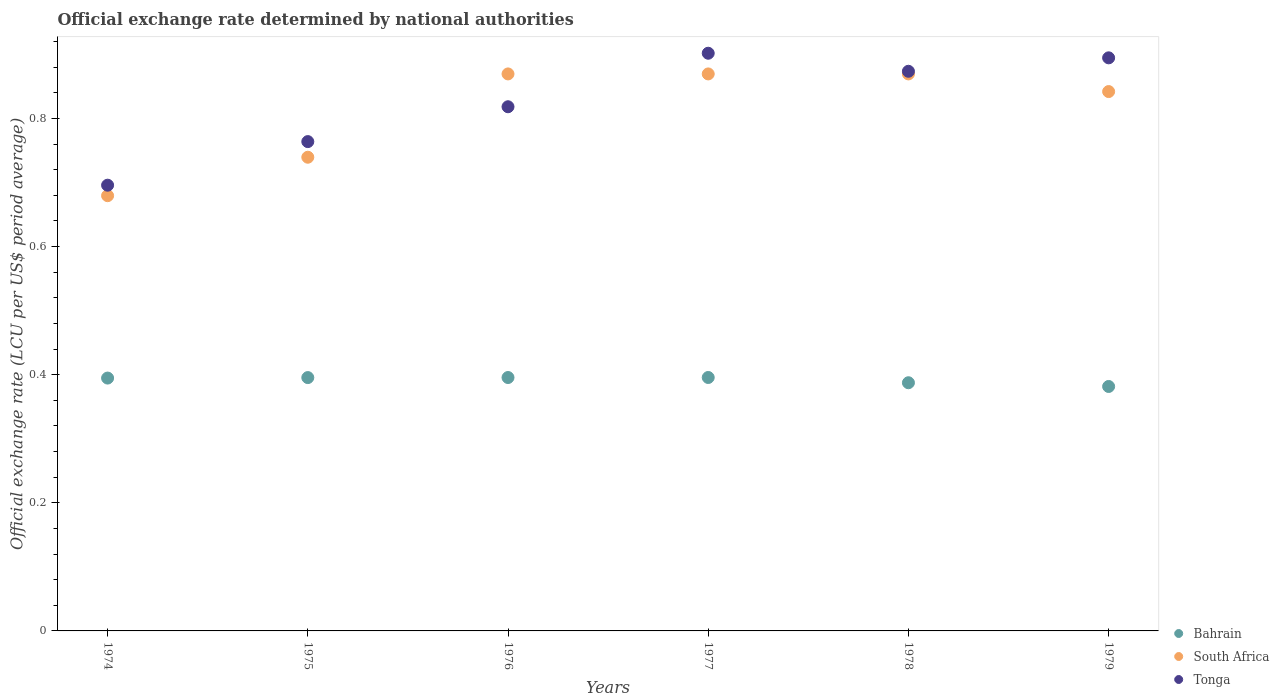What is the official exchange rate in South Africa in 1977?
Provide a succinct answer. 0.87. Across all years, what is the maximum official exchange rate in Bahrain?
Provide a succinct answer. 0.4. Across all years, what is the minimum official exchange rate in Bahrain?
Give a very brief answer. 0.38. In which year was the official exchange rate in South Africa maximum?
Your answer should be compact. 1976. In which year was the official exchange rate in South Africa minimum?
Provide a succinct answer. 1974. What is the total official exchange rate in Bahrain in the graph?
Your answer should be compact. 2.35. What is the difference between the official exchange rate in South Africa in 1975 and that in 1979?
Your response must be concise. -0.1. What is the difference between the official exchange rate in Bahrain in 1976 and the official exchange rate in South Africa in 1977?
Your answer should be very brief. -0.47. What is the average official exchange rate in South Africa per year?
Keep it short and to the point. 0.81. In the year 1977, what is the difference between the official exchange rate in Tonga and official exchange rate in Bahrain?
Offer a very short reply. 0.51. In how many years, is the official exchange rate in Tonga greater than 0.04 LCU?
Offer a terse response. 6. What is the ratio of the official exchange rate in Tonga in 1974 to that in 1978?
Keep it short and to the point. 0.8. Is the difference between the official exchange rate in Tonga in 1976 and 1979 greater than the difference between the official exchange rate in Bahrain in 1976 and 1979?
Make the answer very short. No. What is the difference between the highest and the second highest official exchange rate in South Africa?
Offer a very short reply. 0. What is the difference between the highest and the lowest official exchange rate in Bahrain?
Give a very brief answer. 0.01. Is it the case that in every year, the sum of the official exchange rate in Tonga and official exchange rate in Bahrain  is greater than the official exchange rate in South Africa?
Offer a very short reply. Yes. Does the official exchange rate in Tonga monotonically increase over the years?
Your answer should be compact. No. Is the official exchange rate in South Africa strictly less than the official exchange rate in Bahrain over the years?
Your response must be concise. No. How many dotlines are there?
Your answer should be compact. 3. How many years are there in the graph?
Provide a short and direct response. 6. Does the graph contain any zero values?
Provide a short and direct response. No. Does the graph contain grids?
Your answer should be compact. No. How are the legend labels stacked?
Provide a short and direct response. Vertical. What is the title of the graph?
Provide a succinct answer. Official exchange rate determined by national authorities. Does "Bosnia and Herzegovina" appear as one of the legend labels in the graph?
Ensure brevity in your answer.  No. What is the label or title of the X-axis?
Offer a terse response. Years. What is the label or title of the Y-axis?
Give a very brief answer. Official exchange rate (LCU per US$ period average). What is the Official exchange rate (LCU per US$ period average) of Bahrain in 1974?
Keep it short and to the point. 0.39. What is the Official exchange rate (LCU per US$ period average) in South Africa in 1974?
Your response must be concise. 0.68. What is the Official exchange rate (LCU per US$ period average) of Tonga in 1974?
Provide a succinct answer. 0.7. What is the Official exchange rate (LCU per US$ period average) of Bahrain in 1975?
Give a very brief answer. 0.4. What is the Official exchange rate (LCU per US$ period average) in South Africa in 1975?
Your answer should be compact. 0.74. What is the Official exchange rate (LCU per US$ period average) of Tonga in 1975?
Give a very brief answer. 0.76. What is the Official exchange rate (LCU per US$ period average) of Bahrain in 1976?
Your answer should be very brief. 0.4. What is the Official exchange rate (LCU per US$ period average) in South Africa in 1976?
Offer a terse response. 0.87. What is the Official exchange rate (LCU per US$ period average) in Tonga in 1976?
Ensure brevity in your answer.  0.82. What is the Official exchange rate (LCU per US$ period average) in Bahrain in 1977?
Keep it short and to the point. 0.4. What is the Official exchange rate (LCU per US$ period average) in South Africa in 1977?
Keep it short and to the point. 0.87. What is the Official exchange rate (LCU per US$ period average) of Tonga in 1977?
Ensure brevity in your answer.  0.9. What is the Official exchange rate (LCU per US$ period average) in Bahrain in 1978?
Give a very brief answer. 0.39. What is the Official exchange rate (LCU per US$ period average) in South Africa in 1978?
Provide a short and direct response. 0.87. What is the Official exchange rate (LCU per US$ period average) in Tonga in 1978?
Offer a terse response. 0.87. What is the Official exchange rate (LCU per US$ period average) of Bahrain in 1979?
Offer a very short reply. 0.38. What is the Official exchange rate (LCU per US$ period average) of South Africa in 1979?
Make the answer very short. 0.84. What is the Official exchange rate (LCU per US$ period average) of Tonga in 1979?
Offer a very short reply. 0.89. Across all years, what is the maximum Official exchange rate (LCU per US$ period average) in Bahrain?
Make the answer very short. 0.4. Across all years, what is the maximum Official exchange rate (LCU per US$ period average) in South Africa?
Keep it short and to the point. 0.87. Across all years, what is the maximum Official exchange rate (LCU per US$ period average) of Tonga?
Ensure brevity in your answer.  0.9. Across all years, what is the minimum Official exchange rate (LCU per US$ period average) in Bahrain?
Keep it short and to the point. 0.38. Across all years, what is the minimum Official exchange rate (LCU per US$ period average) in South Africa?
Your response must be concise. 0.68. Across all years, what is the minimum Official exchange rate (LCU per US$ period average) in Tonga?
Offer a terse response. 0.7. What is the total Official exchange rate (LCU per US$ period average) of Bahrain in the graph?
Make the answer very short. 2.35. What is the total Official exchange rate (LCU per US$ period average) of South Africa in the graph?
Offer a terse response. 4.87. What is the total Official exchange rate (LCU per US$ period average) of Tonga in the graph?
Give a very brief answer. 4.95. What is the difference between the Official exchange rate (LCU per US$ period average) of Bahrain in 1974 and that in 1975?
Offer a terse response. -0. What is the difference between the Official exchange rate (LCU per US$ period average) of South Africa in 1974 and that in 1975?
Offer a very short reply. -0.06. What is the difference between the Official exchange rate (LCU per US$ period average) of Tonga in 1974 and that in 1975?
Provide a succinct answer. -0.07. What is the difference between the Official exchange rate (LCU per US$ period average) of Bahrain in 1974 and that in 1976?
Provide a succinct answer. -0. What is the difference between the Official exchange rate (LCU per US$ period average) in South Africa in 1974 and that in 1976?
Keep it short and to the point. -0.19. What is the difference between the Official exchange rate (LCU per US$ period average) of Tonga in 1974 and that in 1976?
Offer a very short reply. -0.12. What is the difference between the Official exchange rate (LCU per US$ period average) of Bahrain in 1974 and that in 1977?
Ensure brevity in your answer.  -0. What is the difference between the Official exchange rate (LCU per US$ period average) in South Africa in 1974 and that in 1977?
Your answer should be very brief. -0.19. What is the difference between the Official exchange rate (LCU per US$ period average) of Tonga in 1974 and that in 1977?
Your response must be concise. -0.21. What is the difference between the Official exchange rate (LCU per US$ period average) in Bahrain in 1974 and that in 1978?
Your response must be concise. 0.01. What is the difference between the Official exchange rate (LCU per US$ period average) in South Africa in 1974 and that in 1978?
Offer a terse response. -0.19. What is the difference between the Official exchange rate (LCU per US$ period average) of Tonga in 1974 and that in 1978?
Offer a very short reply. -0.18. What is the difference between the Official exchange rate (LCU per US$ period average) of Bahrain in 1974 and that in 1979?
Keep it short and to the point. 0.01. What is the difference between the Official exchange rate (LCU per US$ period average) of South Africa in 1974 and that in 1979?
Your answer should be very brief. -0.16. What is the difference between the Official exchange rate (LCU per US$ period average) in Tonga in 1974 and that in 1979?
Provide a short and direct response. -0.2. What is the difference between the Official exchange rate (LCU per US$ period average) of Bahrain in 1975 and that in 1976?
Your response must be concise. -0. What is the difference between the Official exchange rate (LCU per US$ period average) of South Africa in 1975 and that in 1976?
Offer a very short reply. -0.13. What is the difference between the Official exchange rate (LCU per US$ period average) in Tonga in 1975 and that in 1976?
Keep it short and to the point. -0.05. What is the difference between the Official exchange rate (LCU per US$ period average) in Bahrain in 1975 and that in 1977?
Give a very brief answer. -0. What is the difference between the Official exchange rate (LCU per US$ period average) in South Africa in 1975 and that in 1977?
Offer a terse response. -0.13. What is the difference between the Official exchange rate (LCU per US$ period average) in Tonga in 1975 and that in 1977?
Give a very brief answer. -0.14. What is the difference between the Official exchange rate (LCU per US$ period average) of Bahrain in 1975 and that in 1978?
Provide a short and direct response. 0.01. What is the difference between the Official exchange rate (LCU per US$ period average) in South Africa in 1975 and that in 1978?
Give a very brief answer. -0.13. What is the difference between the Official exchange rate (LCU per US$ period average) of Tonga in 1975 and that in 1978?
Your answer should be compact. -0.11. What is the difference between the Official exchange rate (LCU per US$ period average) in Bahrain in 1975 and that in 1979?
Provide a short and direct response. 0.01. What is the difference between the Official exchange rate (LCU per US$ period average) in South Africa in 1975 and that in 1979?
Keep it short and to the point. -0.1. What is the difference between the Official exchange rate (LCU per US$ period average) of Tonga in 1975 and that in 1979?
Your answer should be compact. -0.13. What is the difference between the Official exchange rate (LCU per US$ period average) of Bahrain in 1976 and that in 1977?
Provide a succinct answer. -0. What is the difference between the Official exchange rate (LCU per US$ period average) of South Africa in 1976 and that in 1977?
Offer a very short reply. 0. What is the difference between the Official exchange rate (LCU per US$ period average) of Tonga in 1976 and that in 1977?
Provide a succinct answer. -0.08. What is the difference between the Official exchange rate (LCU per US$ period average) of Bahrain in 1976 and that in 1978?
Offer a terse response. 0.01. What is the difference between the Official exchange rate (LCU per US$ period average) in South Africa in 1976 and that in 1978?
Your answer should be very brief. 0. What is the difference between the Official exchange rate (LCU per US$ period average) in Tonga in 1976 and that in 1978?
Your answer should be compact. -0.06. What is the difference between the Official exchange rate (LCU per US$ period average) in Bahrain in 1976 and that in 1979?
Provide a succinct answer. 0.01. What is the difference between the Official exchange rate (LCU per US$ period average) of South Africa in 1976 and that in 1979?
Provide a short and direct response. 0.03. What is the difference between the Official exchange rate (LCU per US$ period average) of Tonga in 1976 and that in 1979?
Offer a terse response. -0.08. What is the difference between the Official exchange rate (LCU per US$ period average) of Bahrain in 1977 and that in 1978?
Your response must be concise. 0.01. What is the difference between the Official exchange rate (LCU per US$ period average) of South Africa in 1977 and that in 1978?
Provide a short and direct response. 0. What is the difference between the Official exchange rate (LCU per US$ period average) in Tonga in 1977 and that in 1978?
Your response must be concise. 0.03. What is the difference between the Official exchange rate (LCU per US$ period average) in Bahrain in 1977 and that in 1979?
Offer a very short reply. 0.01. What is the difference between the Official exchange rate (LCU per US$ period average) in South Africa in 1977 and that in 1979?
Offer a very short reply. 0.03. What is the difference between the Official exchange rate (LCU per US$ period average) of Tonga in 1977 and that in 1979?
Ensure brevity in your answer.  0.01. What is the difference between the Official exchange rate (LCU per US$ period average) of Bahrain in 1978 and that in 1979?
Your answer should be compact. 0.01. What is the difference between the Official exchange rate (LCU per US$ period average) of South Africa in 1978 and that in 1979?
Ensure brevity in your answer.  0.03. What is the difference between the Official exchange rate (LCU per US$ period average) in Tonga in 1978 and that in 1979?
Give a very brief answer. -0.02. What is the difference between the Official exchange rate (LCU per US$ period average) in Bahrain in 1974 and the Official exchange rate (LCU per US$ period average) in South Africa in 1975?
Your answer should be very brief. -0.34. What is the difference between the Official exchange rate (LCU per US$ period average) in Bahrain in 1974 and the Official exchange rate (LCU per US$ period average) in Tonga in 1975?
Offer a very short reply. -0.37. What is the difference between the Official exchange rate (LCU per US$ period average) of South Africa in 1974 and the Official exchange rate (LCU per US$ period average) of Tonga in 1975?
Provide a succinct answer. -0.08. What is the difference between the Official exchange rate (LCU per US$ period average) of Bahrain in 1974 and the Official exchange rate (LCU per US$ period average) of South Africa in 1976?
Keep it short and to the point. -0.47. What is the difference between the Official exchange rate (LCU per US$ period average) in Bahrain in 1974 and the Official exchange rate (LCU per US$ period average) in Tonga in 1976?
Keep it short and to the point. -0.42. What is the difference between the Official exchange rate (LCU per US$ period average) of South Africa in 1974 and the Official exchange rate (LCU per US$ period average) of Tonga in 1976?
Ensure brevity in your answer.  -0.14. What is the difference between the Official exchange rate (LCU per US$ period average) in Bahrain in 1974 and the Official exchange rate (LCU per US$ period average) in South Africa in 1977?
Give a very brief answer. -0.47. What is the difference between the Official exchange rate (LCU per US$ period average) in Bahrain in 1974 and the Official exchange rate (LCU per US$ period average) in Tonga in 1977?
Offer a very short reply. -0.51. What is the difference between the Official exchange rate (LCU per US$ period average) in South Africa in 1974 and the Official exchange rate (LCU per US$ period average) in Tonga in 1977?
Offer a terse response. -0.22. What is the difference between the Official exchange rate (LCU per US$ period average) in Bahrain in 1974 and the Official exchange rate (LCU per US$ period average) in South Africa in 1978?
Ensure brevity in your answer.  -0.47. What is the difference between the Official exchange rate (LCU per US$ period average) of Bahrain in 1974 and the Official exchange rate (LCU per US$ period average) of Tonga in 1978?
Provide a succinct answer. -0.48. What is the difference between the Official exchange rate (LCU per US$ period average) of South Africa in 1974 and the Official exchange rate (LCU per US$ period average) of Tonga in 1978?
Your response must be concise. -0.19. What is the difference between the Official exchange rate (LCU per US$ period average) of Bahrain in 1974 and the Official exchange rate (LCU per US$ period average) of South Africa in 1979?
Keep it short and to the point. -0.45. What is the difference between the Official exchange rate (LCU per US$ period average) of Bahrain in 1974 and the Official exchange rate (LCU per US$ period average) of Tonga in 1979?
Keep it short and to the point. -0.5. What is the difference between the Official exchange rate (LCU per US$ period average) in South Africa in 1974 and the Official exchange rate (LCU per US$ period average) in Tonga in 1979?
Give a very brief answer. -0.22. What is the difference between the Official exchange rate (LCU per US$ period average) in Bahrain in 1975 and the Official exchange rate (LCU per US$ period average) in South Africa in 1976?
Give a very brief answer. -0.47. What is the difference between the Official exchange rate (LCU per US$ period average) of Bahrain in 1975 and the Official exchange rate (LCU per US$ period average) of Tonga in 1976?
Offer a very short reply. -0.42. What is the difference between the Official exchange rate (LCU per US$ period average) in South Africa in 1975 and the Official exchange rate (LCU per US$ period average) in Tonga in 1976?
Provide a short and direct response. -0.08. What is the difference between the Official exchange rate (LCU per US$ period average) in Bahrain in 1975 and the Official exchange rate (LCU per US$ period average) in South Africa in 1977?
Your answer should be very brief. -0.47. What is the difference between the Official exchange rate (LCU per US$ period average) in Bahrain in 1975 and the Official exchange rate (LCU per US$ period average) in Tonga in 1977?
Ensure brevity in your answer.  -0.51. What is the difference between the Official exchange rate (LCU per US$ period average) of South Africa in 1975 and the Official exchange rate (LCU per US$ period average) of Tonga in 1977?
Give a very brief answer. -0.16. What is the difference between the Official exchange rate (LCU per US$ period average) of Bahrain in 1975 and the Official exchange rate (LCU per US$ period average) of South Africa in 1978?
Keep it short and to the point. -0.47. What is the difference between the Official exchange rate (LCU per US$ period average) of Bahrain in 1975 and the Official exchange rate (LCU per US$ period average) of Tonga in 1978?
Your response must be concise. -0.48. What is the difference between the Official exchange rate (LCU per US$ period average) in South Africa in 1975 and the Official exchange rate (LCU per US$ period average) in Tonga in 1978?
Provide a short and direct response. -0.13. What is the difference between the Official exchange rate (LCU per US$ period average) of Bahrain in 1975 and the Official exchange rate (LCU per US$ period average) of South Africa in 1979?
Give a very brief answer. -0.45. What is the difference between the Official exchange rate (LCU per US$ period average) of Bahrain in 1975 and the Official exchange rate (LCU per US$ period average) of Tonga in 1979?
Ensure brevity in your answer.  -0.5. What is the difference between the Official exchange rate (LCU per US$ period average) of South Africa in 1975 and the Official exchange rate (LCU per US$ period average) of Tonga in 1979?
Make the answer very short. -0.16. What is the difference between the Official exchange rate (LCU per US$ period average) in Bahrain in 1976 and the Official exchange rate (LCU per US$ period average) in South Africa in 1977?
Provide a succinct answer. -0.47. What is the difference between the Official exchange rate (LCU per US$ period average) in Bahrain in 1976 and the Official exchange rate (LCU per US$ period average) in Tonga in 1977?
Your answer should be compact. -0.51. What is the difference between the Official exchange rate (LCU per US$ period average) of South Africa in 1976 and the Official exchange rate (LCU per US$ period average) of Tonga in 1977?
Make the answer very short. -0.03. What is the difference between the Official exchange rate (LCU per US$ period average) in Bahrain in 1976 and the Official exchange rate (LCU per US$ period average) in South Africa in 1978?
Offer a terse response. -0.47. What is the difference between the Official exchange rate (LCU per US$ period average) of Bahrain in 1976 and the Official exchange rate (LCU per US$ period average) of Tonga in 1978?
Make the answer very short. -0.48. What is the difference between the Official exchange rate (LCU per US$ period average) in South Africa in 1976 and the Official exchange rate (LCU per US$ period average) in Tonga in 1978?
Keep it short and to the point. -0. What is the difference between the Official exchange rate (LCU per US$ period average) of Bahrain in 1976 and the Official exchange rate (LCU per US$ period average) of South Africa in 1979?
Offer a terse response. -0.45. What is the difference between the Official exchange rate (LCU per US$ period average) of Bahrain in 1976 and the Official exchange rate (LCU per US$ period average) of Tonga in 1979?
Provide a short and direct response. -0.5. What is the difference between the Official exchange rate (LCU per US$ period average) of South Africa in 1976 and the Official exchange rate (LCU per US$ period average) of Tonga in 1979?
Ensure brevity in your answer.  -0.03. What is the difference between the Official exchange rate (LCU per US$ period average) of Bahrain in 1977 and the Official exchange rate (LCU per US$ period average) of South Africa in 1978?
Your response must be concise. -0.47. What is the difference between the Official exchange rate (LCU per US$ period average) of Bahrain in 1977 and the Official exchange rate (LCU per US$ period average) of Tonga in 1978?
Ensure brevity in your answer.  -0.48. What is the difference between the Official exchange rate (LCU per US$ period average) in South Africa in 1977 and the Official exchange rate (LCU per US$ period average) in Tonga in 1978?
Offer a terse response. -0. What is the difference between the Official exchange rate (LCU per US$ period average) in Bahrain in 1977 and the Official exchange rate (LCU per US$ period average) in South Africa in 1979?
Ensure brevity in your answer.  -0.45. What is the difference between the Official exchange rate (LCU per US$ period average) in Bahrain in 1977 and the Official exchange rate (LCU per US$ period average) in Tonga in 1979?
Give a very brief answer. -0.5. What is the difference between the Official exchange rate (LCU per US$ period average) in South Africa in 1977 and the Official exchange rate (LCU per US$ period average) in Tonga in 1979?
Ensure brevity in your answer.  -0.03. What is the difference between the Official exchange rate (LCU per US$ period average) of Bahrain in 1978 and the Official exchange rate (LCU per US$ period average) of South Africa in 1979?
Offer a terse response. -0.45. What is the difference between the Official exchange rate (LCU per US$ period average) of Bahrain in 1978 and the Official exchange rate (LCU per US$ period average) of Tonga in 1979?
Provide a short and direct response. -0.51. What is the difference between the Official exchange rate (LCU per US$ period average) in South Africa in 1978 and the Official exchange rate (LCU per US$ period average) in Tonga in 1979?
Give a very brief answer. -0.03. What is the average Official exchange rate (LCU per US$ period average) of Bahrain per year?
Offer a very short reply. 0.39. What is the average Official exchange rate (LCU per US$ period average) in South Africa per year?
Ensure brevity in your answer.  0.81. What is the average Official exchange rate (LCU per US$ period average) in Tonga per year?
Provide a succinct answer. 0.82. In the year 1974, what is the difference between the Official exchange rate (LCU per US$ period average) of Bahrain and Official exchange rate (LCU per US$ period average) of South Africa?
Make the answer very short. -0.28. In the year 1974, what is the difference between the Official exchange rate (LCU per US$ period average) of Bahrain and Official exchange rate (LCU per US$ period average) of Tonga?
Ensure brevity in your answer.  -0.3. In the year 1974, what is the difference between the Official exchange rate (LCU per US$ period average) of South Africa and Official exchange rate (LCU per US$ period average) of Tonga?
Your response must be concise. -0.02. In the year 1975, what is the difference between the Official exchange rate (LCU per US$ period average) in Bahrain and Official exchange rate (LCU per US$ period average) in South Africa?
Your response must be concise. -0.34. In the year 1975, what is the difference between the Official exchange rate (LCU per US$ period average) in Bahrain and Official exchange rate (LCU per US$ period average) in Tonga?
Keep it short and to the point. -0.37. In the year 1975, what is the difference between the Official exchange rate (LCU per US$ period average) of South Africa and Official exchange rate (LCU per US$ period average) of Tonga?
Ensure brevity in your answer.  -0.02. In the year 1976, what is the difference between the Official exchange rate (LCU per US$ period average) of Bahrain and Official exchange rate (LCU per US$ period average) of South Africa?
Keep it short and to the point. -0.47. In the year 1976, what is the difference between the Official exchange rate (LCU per US$ period average) in Bahrain and Official exchange rate (LCU per US$ period average) in Tonga?
Give a very brief answer. -0.42. In the year 1976, what is the difference between the Official exchange rate (LCU per US$ period average) in South Africa and Official exchange rate (LCU per US$ period average) in Tonga?
Provide a short and direct response. 0.05. In the year 1977, what is the difference between the Official exchange rate (LCU per US$ period average) of Bahrain and Official exchange rate (LCU per US$ period average) of South Africa?
Ensure brevity in your answer.  -0.47. In the year 1977, what is the difference between the Official exchange rate (LCU per US$ period average) of Bahrain and Official exchange rate (LCU per US$ period average) of Tonga?
Keep it short and to the point. -0.51. In the year 1977, what is the difference between the Official exchange rate (LCU per US$ period average) of South Africa and Official exchange rate (LCU per US$ period average) of Tonga?
Offer a terse response. -0.03. In the year 1978, what is the difference between the Official exchange rate (LCU per US$ period average) in Bahrain and Official exchange rate (LCU per US$ period average) in South Africa?
Offer a terse response. -0.48. In the year 1978, what is the difference between the Official exchange rate (LCU per US$ period average) in Bahrain and Official exchange rate (LCU per US$ period average) in Tonga?
Your response must be concise. -0.49. In the year 1978, what is the difference between the Official exchange rate (LCU per US$ period average) in South Africa and Official exchange rate (LCU per US$ period average) in Tonga?
Make the answer very short. -0. In the year 1979, what is the difference between the Official exchange rate (LCU per US$ period average) in Bahrain and Official exchange rate (LCU per US$ period average) in South Africa?
Keep it short and to the point. -0.46. In the year 1979, what is the difference between the Official exchange rate (LCU per US$ period average) of Bahrain and Official exchange rate (LCU per US$ period average) of Tonga?
Give a very brief answer. -0.51. In the year 1979, what is the difference between the Official exchange rate (LCU per US$ period average) of South Africa and Official exchange rate (LCU per US$ period average) of Tonga?
Your response must be concise. -0.05. What is the ratio of the Official exchange rate (LCU per US$ period average) in South Africa in 1974 to that in 1975?
Offer a terse response. 0.92. What is the ratio of the Official exchange rate (LCU per US$ period average) in Tonga in 1974 to that in 1975?
Your answer should be compact. 0.91. What is the ratio of the Official exchange rate (LCU per US$ period average) in Bahrain in 1974 to that in 1976?
Provide a short and direct response. 1. What is the ratio of the Official exchange rate (LCU per US$ period average) of South Africa in 1974 to that in 1976?
Keep it short and to the point. 0.78. What is the ratio of the Official exchange rate (LCU per US$ period average) of Tonga in 1974 to that in 1976?
Provide a succinct answer. 0.85. What is the ratio of the Official exchange rate (LCU per US$ period average) of South Africa in 1974 to that in 1977?
Provide a succinct answer. 0.78. What is the ratio of the Official exchange rate (LCU per US$ period average) of Tonga in 1974 to that in 1977?
Provide a succinct answer. 0.77. What is the ratio of the Official exchange rate (LCU per US$ period average) in Bahrain in 1974 to that in 1978?
Provide a short and direct response. 1.02. What is the ratio of the Official exchange rate (LCU per US$ period average) of South Africa in 1974 to that in 1978?
Your answer should be very brief. 0.78. What is the ratio of the Official exchange rate (LCU per US$ period average) in Tonga in 1974 to that in 1978?
Offer a terse response. 0.8. What is the ratio of the Official exchange rate (LCU per US$ period average) of Bahrain in 1974 to that in 1979?
Make the answer very short. 1.03. What is the ratio of the Official exchange rate (LCU per US$ period average) of South Africa in 1974 to that in 1979?
Provide a short and direct response. 0.81. What is the ratio of the Official exchange rate (LCU per US$ period average) of Tonga in 1974 to that in 1979?
Make the answer very short. 0.78. What is the ratio of the Official exchange rate (LCU per US$ period average) of South Africa in 1975 to that in 1976?
Give a very brief answer. 0.85. What is the ratio of the Official exchange rate (LCU per US$ period average) in Tonga in 1975 to that in 1976?
Make the answer very short. 0.93. What is the ratio of the Official exchange rate (LCU per US$ period average) in South Africa in 1975 to that in 1977?
Your answer should be very brief. 0.85. What is the ratio of the Official exchange rate (LCU per US$ period average) of Tonga in 1975 to that in 1977?
Your answer should be compact. 0.85. What is the ratio of the Official exchange rate (LCU per US$ period average) of Bahrain in 1975 to that in 1978?
Offer a very short reply. 1.02. What is the ratio of the Official exchange rate (LCU per US$ period average) of South Africa in 1975 to that in 1978?
Provide a short and direct response. 0.85. What is the ratio of the Official exchange rate (LCU per US$ period average) of Tonga in 1975 to that in 1978?
Your answer should be compact. 0.87. What is the ratio of the Official exchange rate (LCU per US$ period average) of Bahrain in 1975 to that in 1979?
Ensure brevity in your answer.  1.04. What is the ratio of the Official exchange rate (LCU per US$ period average) of South Africa in 1975 to that in 1979?
Make the answer very short. 0.88. What is the ratio of the Official exchange rate (LCU per US$ period average) in Tonga in 1975 to that in 1979?
Your answer should be compact. 0.85. What is the ratio of the Official exchange rate (LCU per US$ period average) in Bahrain in 1976 to that in 1977?
Give a very brief answer. 1. What is the ratio of the Official exchange rate (LCU per US$ period average) in Tonga in 1976 to that in 1977?
Keep it short and to the point. 0.91. What is the ratio of the Official exchange rate (LCU per US$ period average) in Tonga in 1976 to that in 1978?
Give a very brief answer. 0.94. What is the ratio of the Official exchange rate (LCU per US$ period average) in Bahrain in 1976 to that in 1979?
Provide a succinct answer. 1.04. What is the ratio of the Official exchange rate (LCU per US$ period average) in South Africa in 1976 to that in 1979?
Offer a terse response. 1.03. What is the ratio of the Official exchange rate (LCU per US$ period average) of Tonga in 1976 to that in 1979?
Keep it short and to the point. 0.91. What is the ratio of the Official exchange rate (LCU per US$ period average) in Bahrain in 1977 to that in 1978?
Ensure brevity in your answer.  1.02. What is the ratio of the Official exchange rate (LCU per US$ period average) in South Africa in 1977 to that in 1978?
Your answer should be compact. 1. What is the ratio of the Official exchange rate (LCU per US$ period average) of Tonga in 1977 to that in 1978?
Provide a succinct answer. 1.03. What is the ratio of the Official exchange rate (LCU per US$ period average) of Bahrain in 1977 to that in 1979?
Offer a terse response. 1.04. What is the ratio of the Official exchange rate (LCU per US$ period average) in South Africa in 1977 to that in 1979?
Offer a terse response. 1.03. What is the ratio of the Official exchange rate (LCU per US$ period average) of Bahrain in 1978 to that in 1979?
Provide a succinct answer. 1.02. What is the ratio of the Official exchange rate (LCU per US$ period average) in South Africa in 1978 to that in 1979?
Offer a terse response. 1.03. What is the ratio of the Official exchange rate (LCU per US$ period average) of Tonga in 1978 to that in 1979?
Offer a terse response. 0.98. What is the difference between the highest and the second highest Official exchange rate (LCU per US$ period average) of Bahrain?
Offer a terse response. 0. What is the difference between the highest and the second highest Official exchange rate (LCU per US$ period average) in South Africa?
Provide a succinct answer. 0. What is the difference between the highest and the second highest Official exchange rate (LCU per US$ period average) in Tonga?
Give a very brief answer. 0.01. What is the difference between the highest and the lowest Official exchange rate (LCU per US$ period average) of Bahrain?
Give a very brief answer. 0.01. What is the difference between the highest and the lowest Official exchange rate (LCU per US$ period average) of South Africa?
Offer a terse response. 0.19. What is the difference between the highest and the lowest Official exchange rate (LCU per US$ period average) of Tonga?
Offer a terse response. 0.21. 